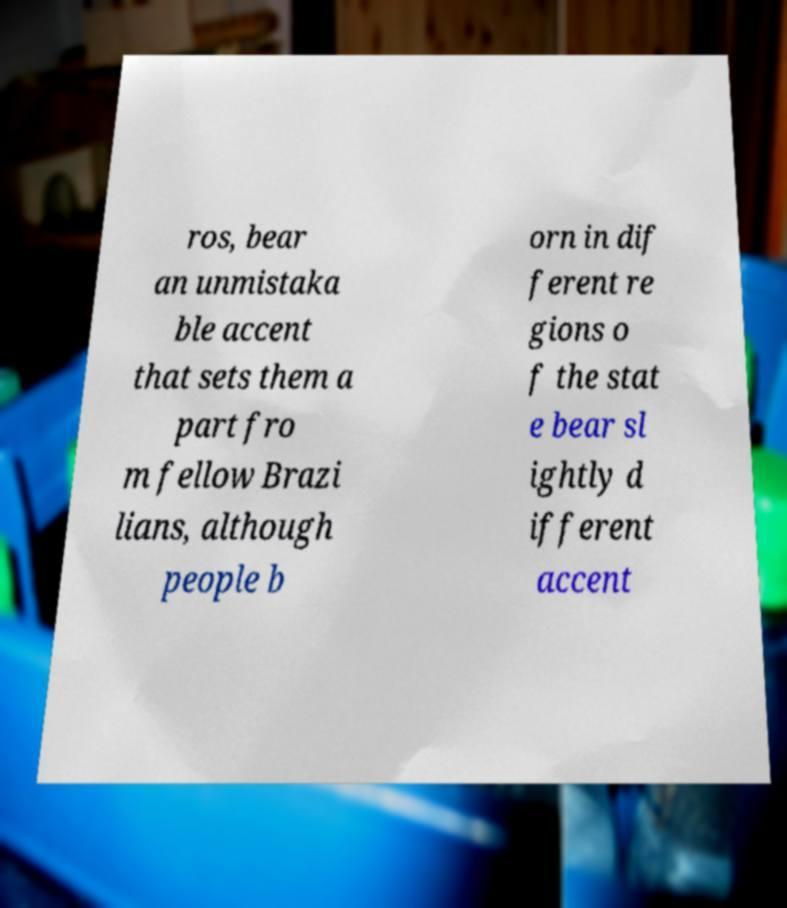Please identify and transcribe the text found in this image. ros, bear an unmistaka ble accent that sets them a part fro m fellow Brazi lians, although people b orn in dif ferent re gions o f the stat e bear sl ightly d ifferent accent 